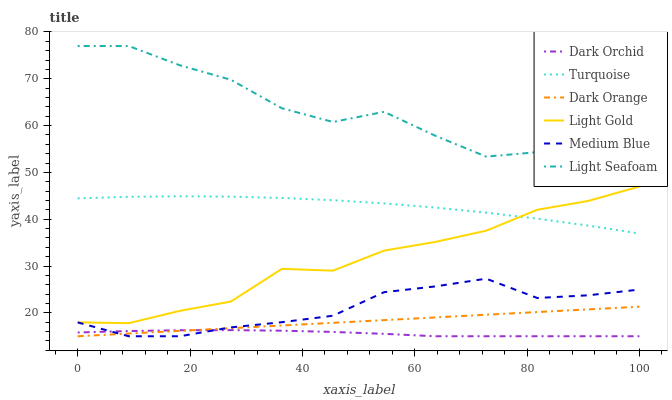Does Dark Orchid have the minimum area under the curve?
Answer yes or no. Yes. Does Light Seafoam have the maximum area under the curve?
Answer yes or no. Yes. Does Turquoise have the minimum area under the curve?
Answer yes or no. No. Does Turquoise have the maximum area under the curve?
Answer yes or no. No. Is Dark Orange the smoothest?
Answer yes or no. Yes. Is Light Seafoam the roughest?
Answer yes or no. Yes. Is Turquoise the smoothest?
Answer yes or no. No. Is Turquoise the roughest?
Answer yes or no. No. Does Dark Orange have the lowest value?
Answer yes or no. Yes. Does Turquoise have the lowest value?
Answer yes or no. No. Does Light Seafoam have the highest value?
Answer yes or no. Yes. Does Turquoise have the highest value?
Answer yes or no. No. Is Medium Blue less than Turquoise?
Answer yes or no. Yes. Is Light Seafoam greater than Light Gold?
Answer yes or no. Yes. Does Medium Blue intersect Dark Orchid?
Answer yes or no. Yes. Is Medium Blue less than Dark Orchid?
Answer yes or no. No. Is Medium Blue greater than Dark Orchid?
Answer yes or no. No. Does Medium Blue intersect Turquoise?
Answer yes or no. No. 